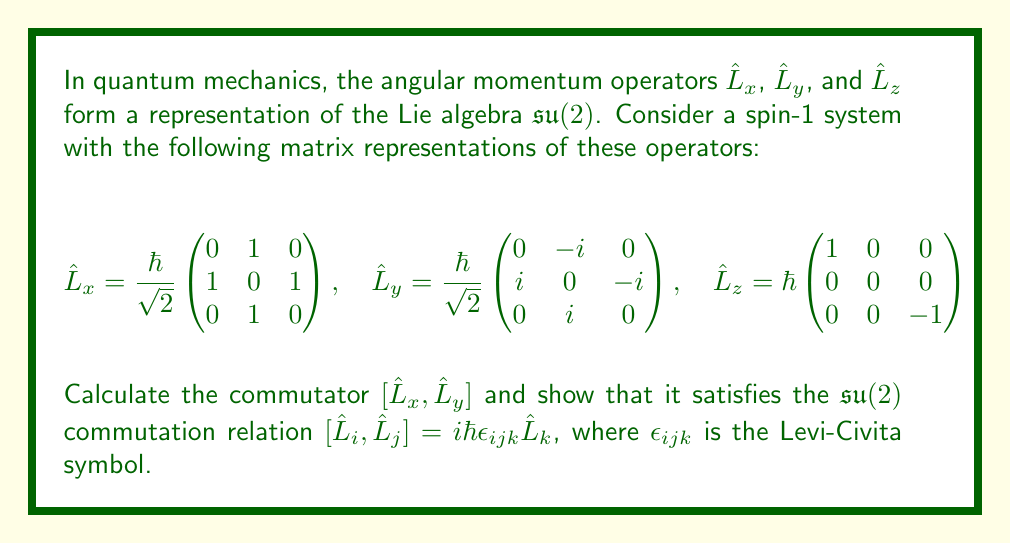Teach me how to tackle this problem. To solve this problem, we'll follow these steps:

1) Calculate the matrix product $\hat{L}_x\hat{L}_y$
2) Calculate the matrix product $\hat{L}_y\hat{L}_x$
3) Compute the commutator $[\hat{L}_x, \hat{L}_y] = \hat{L}_x\hat{L}_y - \hat{L}_y\hat{L}_x$
4) Compare the result with $i\hbar\hat{L}_z$

Step 1: Calculate $\hat{L}_x\hat{L}_y$

$$\hat{L}_x\hat{L}_y = \frac{\hbar^2}{2} \begin{pmatrix}
0 & 1 & 0 \\
1 & 0 & 1 \\
0 & 1 & 0
\end{pmatrix}
\begin{pmatrix}
0 & -i & 0 \\
i & 0 & -i \\
0 & i & 0
\end{pmatrix}
= \frac{\hbar^2}{2} \begin{pmatrix}
i & 0 & -i \\
0 & 0 & 0 \\
-i & 0 & i
\end{pmatrix}$$

Step 2: Calculate $\hat{L}_y\hat{L}_x$

$$\hat{L}_y\hat{L}_x = \frac{\hbar^2}{2} \begin{pmatrix}
0 & -i & 0 \\
i & 0 & -i \\
0 & i & 0
\end{pmatrix}
\begin{pmatrix}
0 & 1 & 0 \\
1 & 0 & 1 \\
0 & 1 & 0
\end{pmatrix}
= \frac{\hbar^2}{2} \begin{pmatrix}
-i & 0 & i \\
0 & 0 & 0 \\
i & 0 & -i
\end{pmatrix}$$

Step 3: Compute the commutator

$$[\hat{L}_x, \hat{L}_y] = \hat{L}_x\hat{L}_y - \hat{L}_y\hat{L}_x
= \frac{\hbar^2}{2} \begin{pmatrix}
i & 0 & -i \\
0 & 0 & 0 \\
-i & 0 & i
\end{pmatrix} - \frac{\hbar^2}{2} \begin{pmatrix}
-i & 0 & i \\
0 & 0 & 0 \\
i & 0 & -i
\end{pmatrix}
= \hbar^2 \begin{pmatrix}
i & 0 & 0 \\
0 & 0 & 0 \\
0 & 0 & -i
\end{pmatrix}$$

Step 4: Compare with $i\hbar\hat{L}_z$

$$i\hbar\hat{L}_z = i\hbar^2 \begin{pmatrix}
1 & 0 & 0 \\
0 & 0 & 0 \\
0 & 0 & -1
\end{pmatrix} = \hbar^2 \begin{pmatrix}
i & 0 & 0 \\
0 & 0 & 0 \\
0 & 0 & -i
\end{pmatrix}$$

We can see that $[\hat{L}_x, \hat{L}_y] = i\hbar\hat{L}_z$, which satisfies the $\mathfrak{su}(2)$ commutation relation $[\hat{L}_i, \hat{L}_j] = i\hbar\epsilon_{ijk}\hat{L}_k$ for $i=x$, $j=y$, and $k=z$.
Answer: $[\hat{L}_x, \hat{L}_y] = i\hbar\hat{L}_z = \hbar^2 \begin{pmatrix}
i & 0 & 0 \\
0 & 0 & 0 \\
0 & 0 & -i
\end{pmatrix}$ 